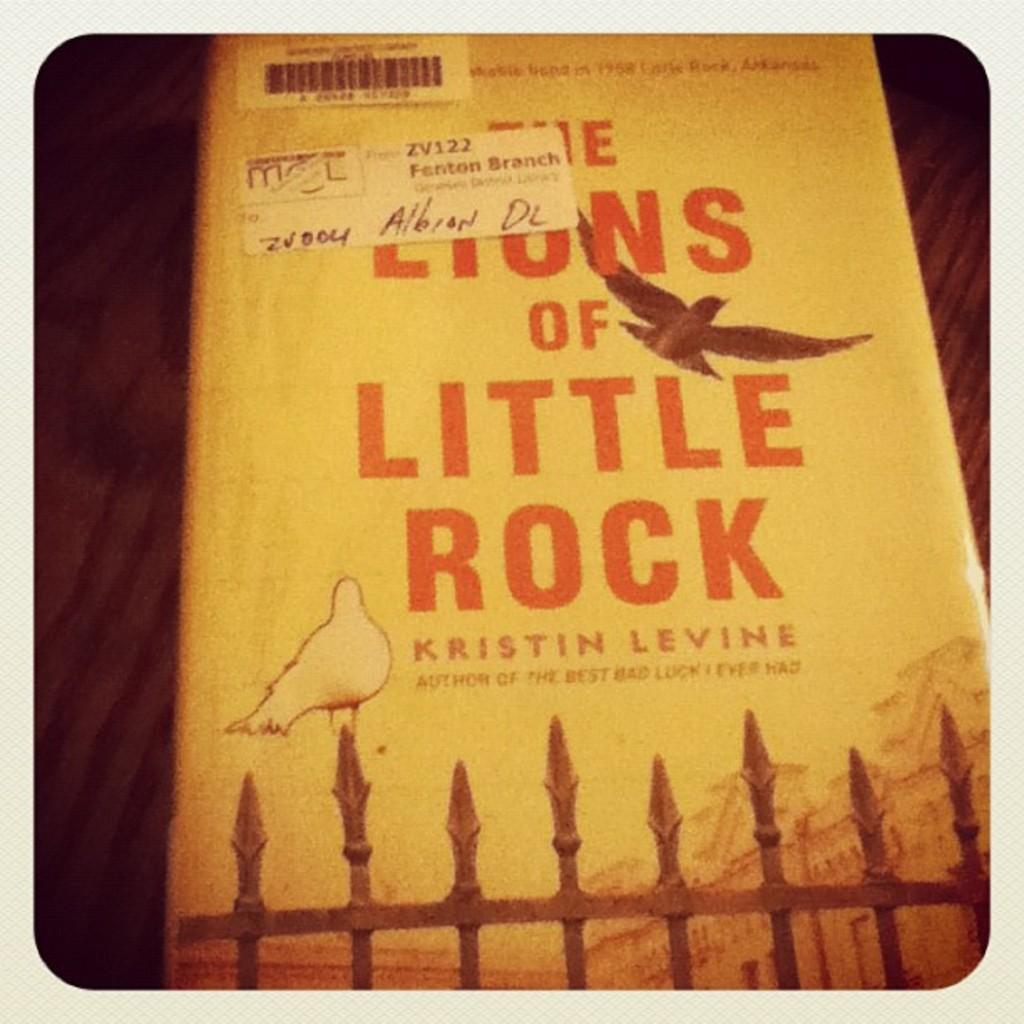<image>
Create a compact narrative representing the image presented. A book by Kristin Levine has a yellow cover with birds on it. 